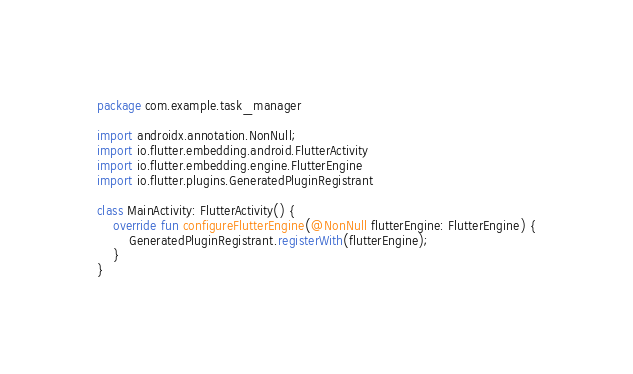<code> <loc_0><loc_0><loc_500><loc_500><_Kotlin_>package com.example.task_manager

import androidx.annotation.NonNull;
import io.flutter.embedding.android.FlutterActivity
import io.flutter.embedding.engine.FlutterEngine
import io.flutter.plugins.GeneratedPluginRegistrant

class MainActivity: FlutterActivity() {
    override fun configureFlutterEngine(@NonNull flutterEngine: FlutterEngine) {
        GeneratedPluginRegistrant.registerWith(flutterEngine);
    }
}
</code> 